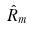<formula> <loc_0><loc_0><loc_500><loc_500>\hat { R } _ { m }</formula> 